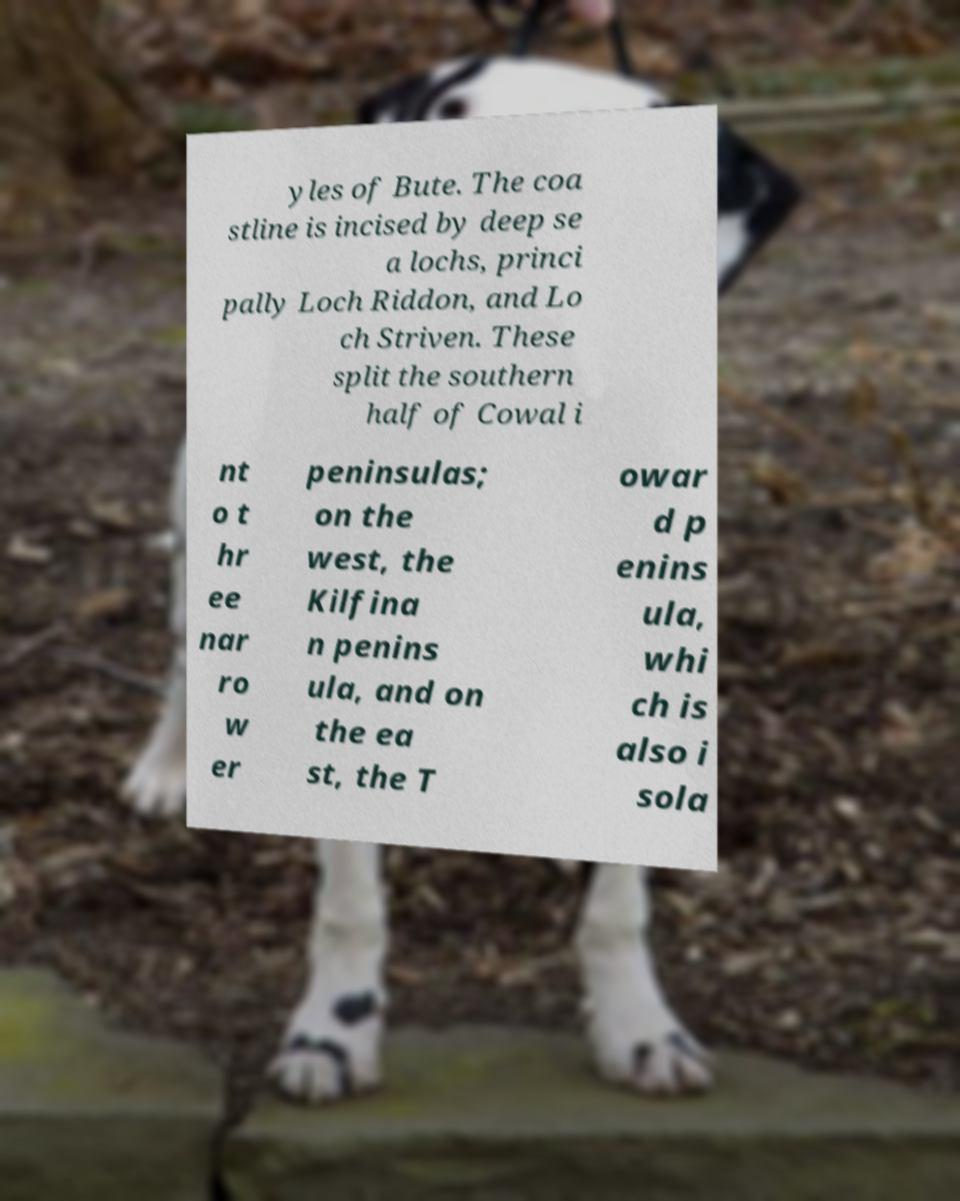Can you accurately transcribe the text from the provided image for me? yles of Bute. The coa stline is incised by deep se a lochs, princi pally Loch Riddon, and Lo ch Striven. These split the southern half of Cowal i nt o t hr ee nar ro w er peninsulas; on the west, the Kilfina n penins ula, and on the ea st, the T owar d p enins ula, whi ch is also i sola 